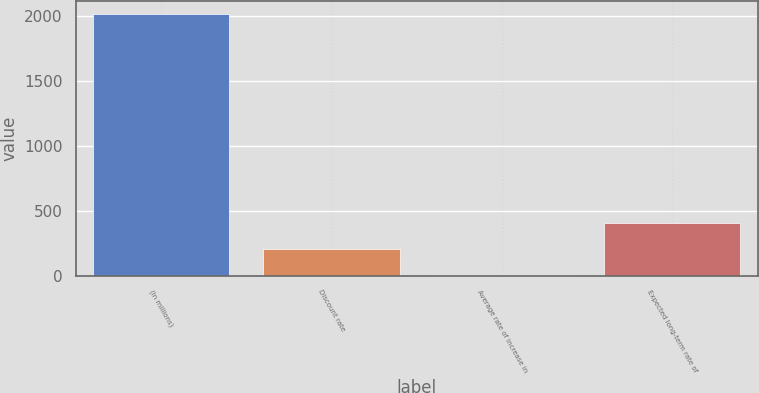Convert chart. <chart><loc_0><loc_0><loc_500><loc_500><bar_chart><fcel>(In millions)<fcel>Discount rate<fcel>Average rate of increase in<fcel>Expected long-term rate of<nl><fcel>2010<fcel>204.6<fcel>4<fcel>405.2<nl></chart> 